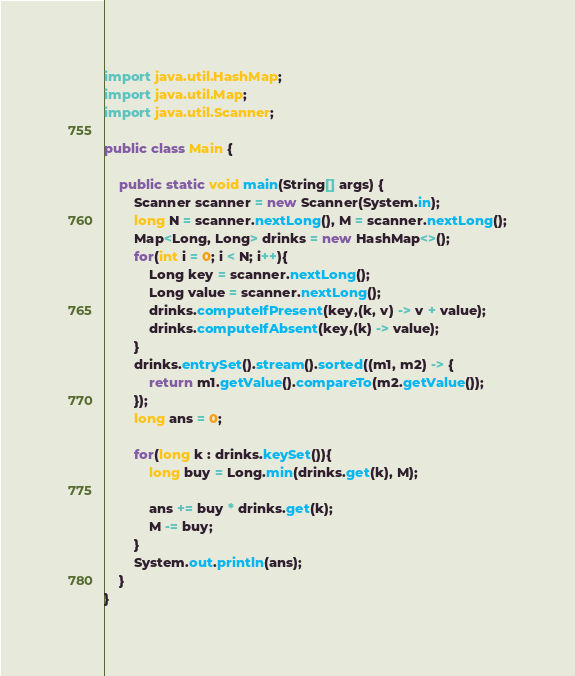<code> <loc_0><loc_0><loc_500><loc_500><_Java_>import java.util.HashMap;
import java.util.Map;
import java.util.Scanner;

public class Main {

    public static void main(String[] args) {
        Scanner scanner = new Scanner(System.in);
        long N = scanner.nextLong(), M = scanner.nextLong();
        Map<Long, Long> drinks = new HashMap<>();
        for(int i = 0; i < N; i++){
            Long key = scanner.nextLong();
            Long value = scanner.nextLong();
            drinks.computeIfPresent(key,(k, v) -> v + value);
            drinks.computeIfAbsent(key,(k) -> value);
        }
        drinks.entrySet().stream().sorted((m1, m2) -> {
            return m1.getValue().compareTo(m2.getValue());
        });
        long ans = 0;

        for(long k : drinks.keySet()){
            long buy = Long.min(drinks.get(k), M);

            ans += buy * drinks.get(k);
            M -= buy;
        }
        System.out.println(ans);
    }
}</code> 